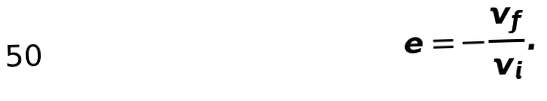<formula> <loc_0><loc_0><loc_500><loc_500>e = - { \frac { v _ { f } } { v _ { i } } } .</formula> 